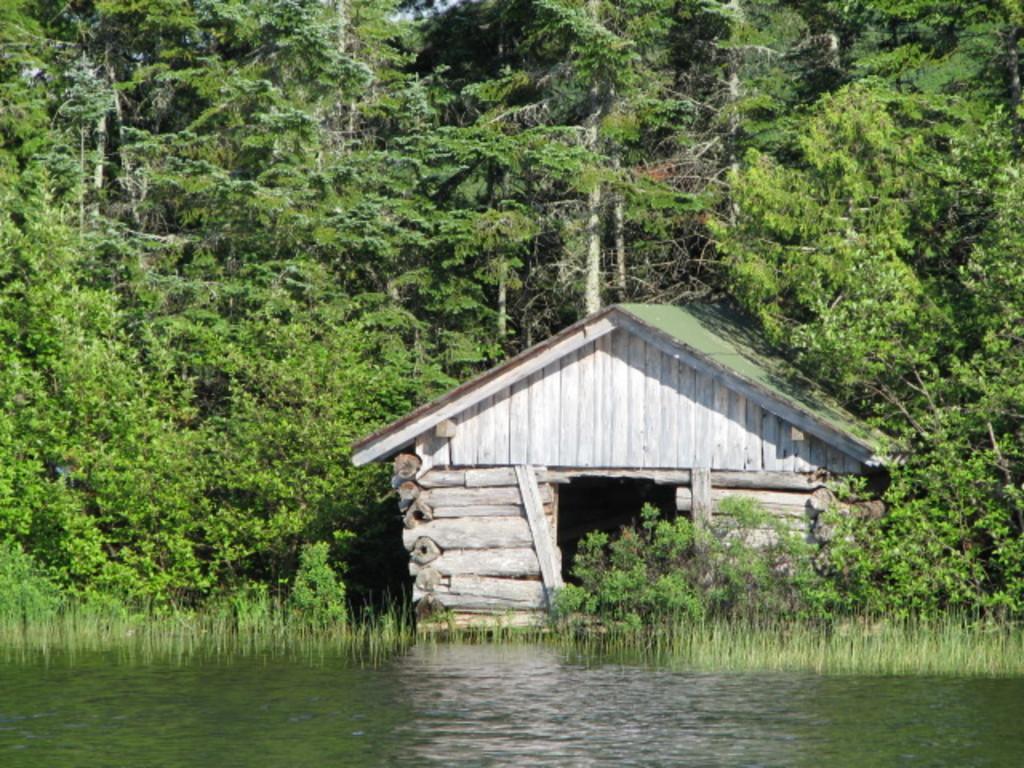How would you summarize this image in a sentence or two? In this image we can see a house, in front of the house we can see some water and grass, there are some trees and the sky. 